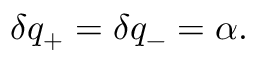Convert formula to latex. <formula><loc_0><loc_0><loc_500><loc_500>\delta q _ { + } = \delta q _ { - } = \alpha .</formula> 